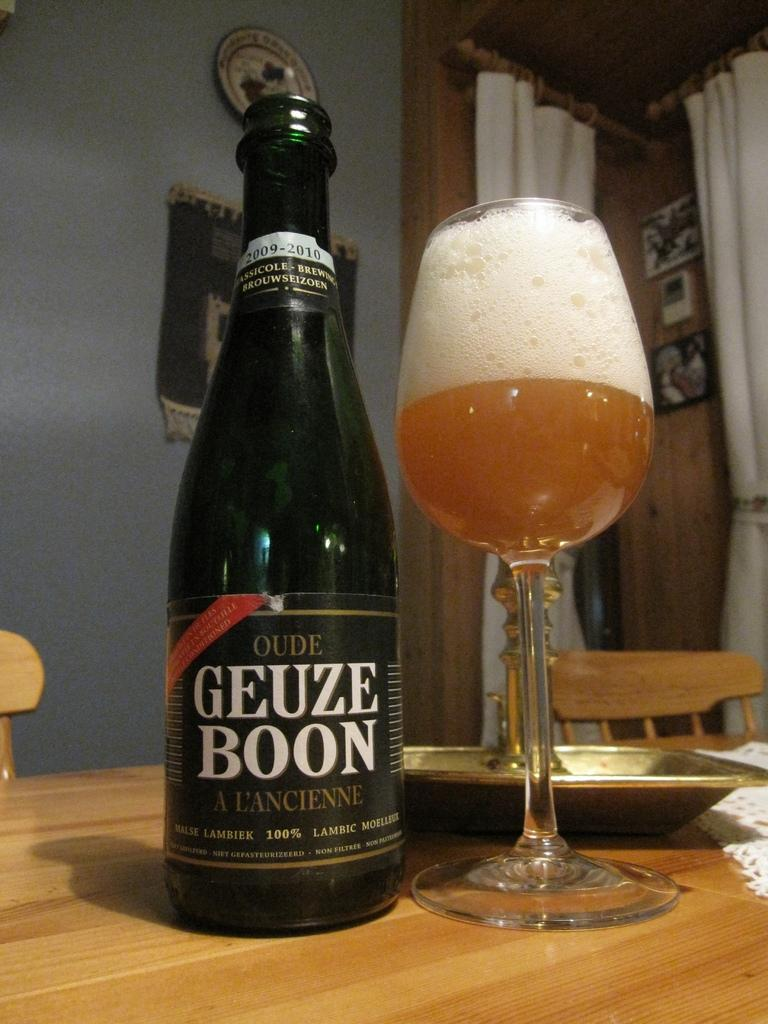<image>
Create a compact narrative representing the image presented. A bottle of Geuze Boon sits next to a half-full glass that has a lot of foam in it. 